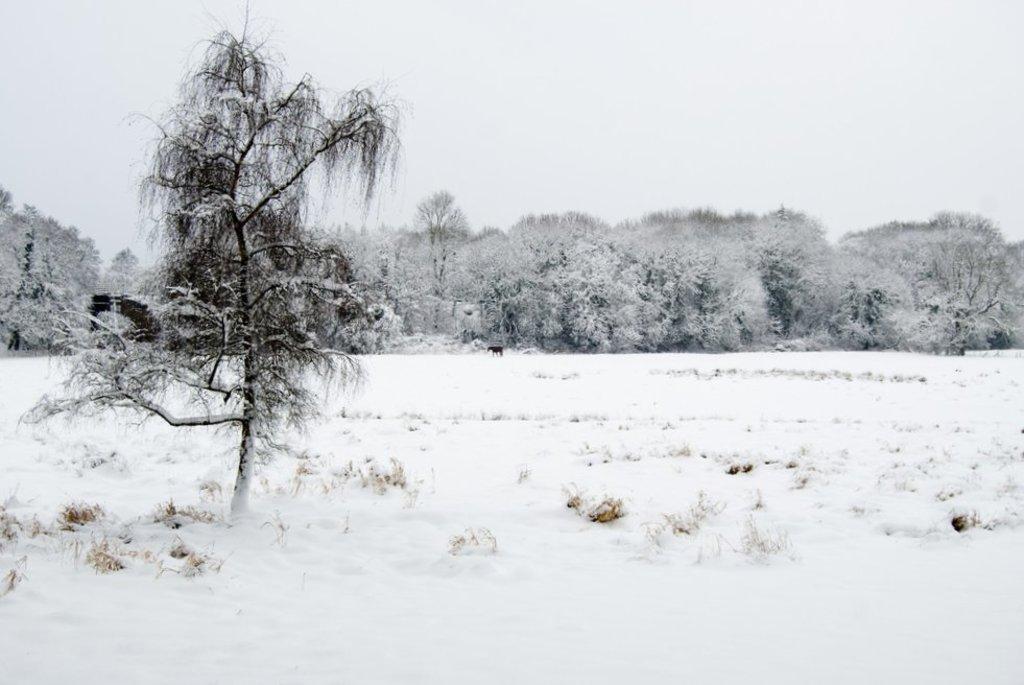Describe this image in one or two sentences. In the picture I can see trees, the snow and the grass. In the background I can see the sky. 